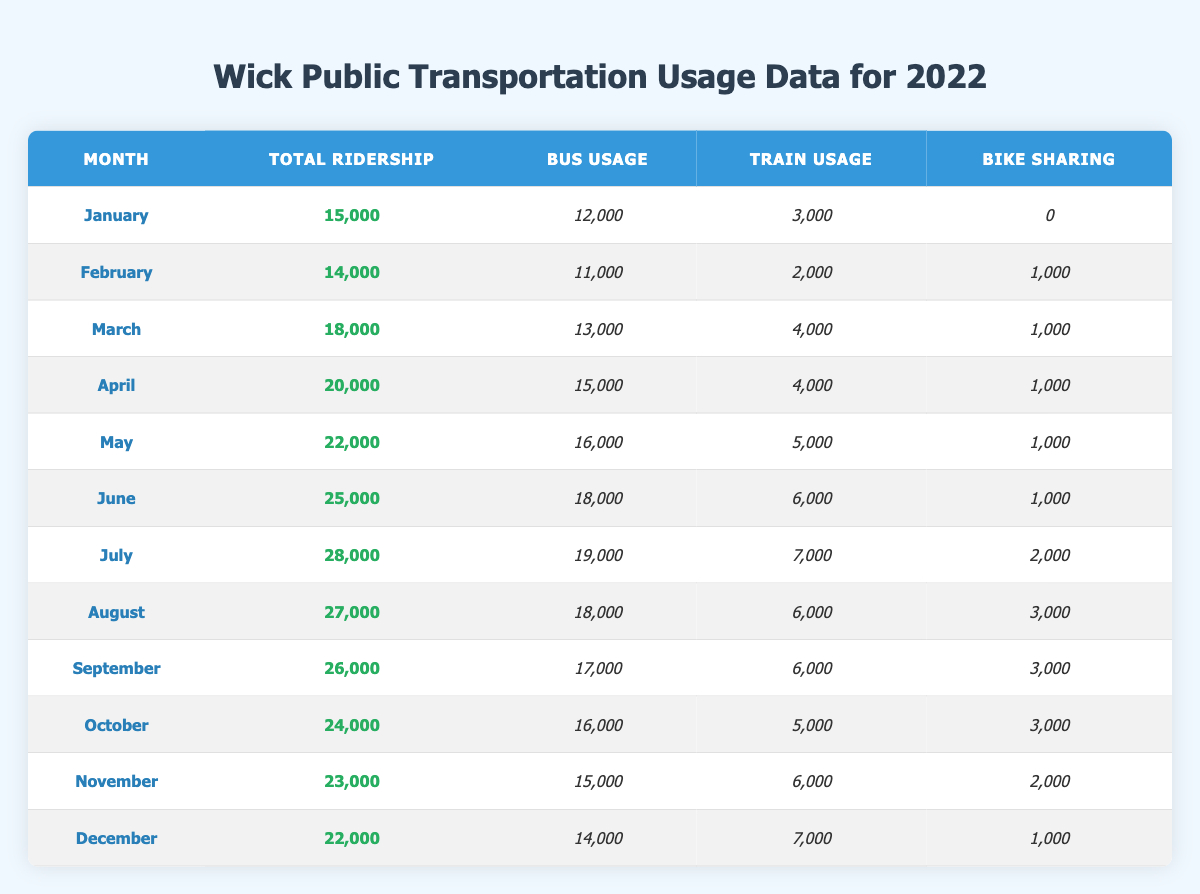What was the total ridership in June? The table shows that the total ridership for June is noted in the corresponding cell, which is 25,000.
Answer: 25,000 How much did bike sharing usage increase from January to July? In January, bike sharing usage was 0, and in July, it was 2,000. The increase is 2,000 - 0 = 2,000.
Answer: 2,000 Which month had the highest bus usage? By reviewing the bus usage for each month, it is clear that July had the highest bus usage at 19,000.
Answer: 19,000 What percentage of total ridership in April was bus usage? To find the percentage, divide the bus usage in April (15,000) by the total ridership (20,000) and multiply by 100: (15,000 / 20,000) * 100 = 75%.
Answer: 75% Was bike sharing used more in August than September? In August, bike sharing was used 3,000 times, while in September, it was also 3,000. Since they are equal, the answer is no.
Answer: No Calculate the average train usage across all months. The total train usage across all months is 3,000 + 2,000 + 4,000 + 4,000 + 5,000 + 6,000 + 7,000 + 6,000 + 6,000 + 5,000 + 6,000 + 7,000 = 57,000. Since there are 12 months, the average train usage is 57,000 / 12 = 4,750.
Answer: 4,750 Which month had the greatest difference between total ridership and bus usage? The differences are: January (3,000), February (3,000), March (5,000), April (5,000), May (6,000), June (7,000), July (9,000), August (9,000), September (9,000), October (8,000), November (8,000), December (8,000). July had the greatest difference of 9,000.
Answer: July In which month did bike sharing first appear? Bike sharing first appeared in February, where usage is recorded at 1,000.
Answer: February How does the total ridership in October compare to that in December? The total ridership in October is 24,000, while in December it is 22,000. October has 2,000 more riders than December.
Answer: October has 2,000 more riders What was the trend in bus usage from January to December? By looking at the bus usage figures from January (12,000) to December (14,000), we can see that there is a general increase over the months, with some fluctuations but a net gain overall.
Answer: Increasing trend 